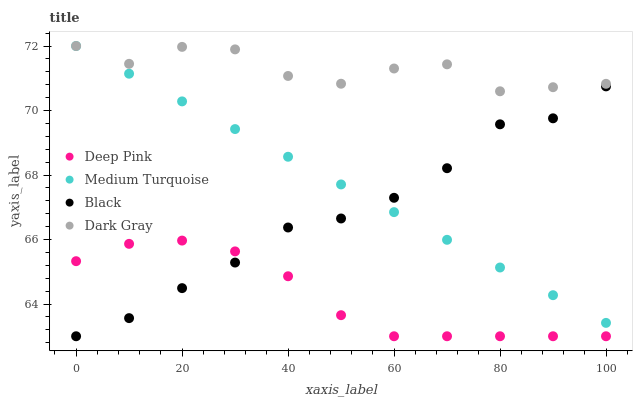Does Deep Pink have the minimum area under the curve?
Answer yes or no. Yes. Does Dark Gray have the maximum area under the curve?
Answer yes or no. Yes. Does Black have the minimum area under the curve?
Answer yes or no. No. Does Black have the maximum area under the curve?
Answer yes or no. No. Is Medium Turquoise the smoothest?
Answer yes or no. Yes. Is Dark Gray the roughest?
Answer yes or no. Yes. Is Deep Pink the smoothest?
Answer yes or no. No. Is Deep Pink the roughest?
Answer yes or no. No. Does Deep Pink have the lowest value?
Answer yes or no. Yes. Does Medium Turquoise have the lowest value?
Answer yes or no. No. Does Medium Turquoise have the highest value?
Answer yes or no. Yes. Does Black have the highest value?
Answer yes or no. No. Is Black less than Dark Gray?
Answer yes or no. Yes. Is Medium Turquoise greater than Deep Pink?
Answer yes or no. Yes. Does Dark Gray intersect Medium Turquoise?
Answer yes or no. Yes. Is Dark Gray less than Medium Turquoise?
Answer yes or no. No. Is Dark Gray greater than Medium Turquoise?
Answer yes or no. No. Does Black intersect Dark Gray?
Answer yes or no. No. 